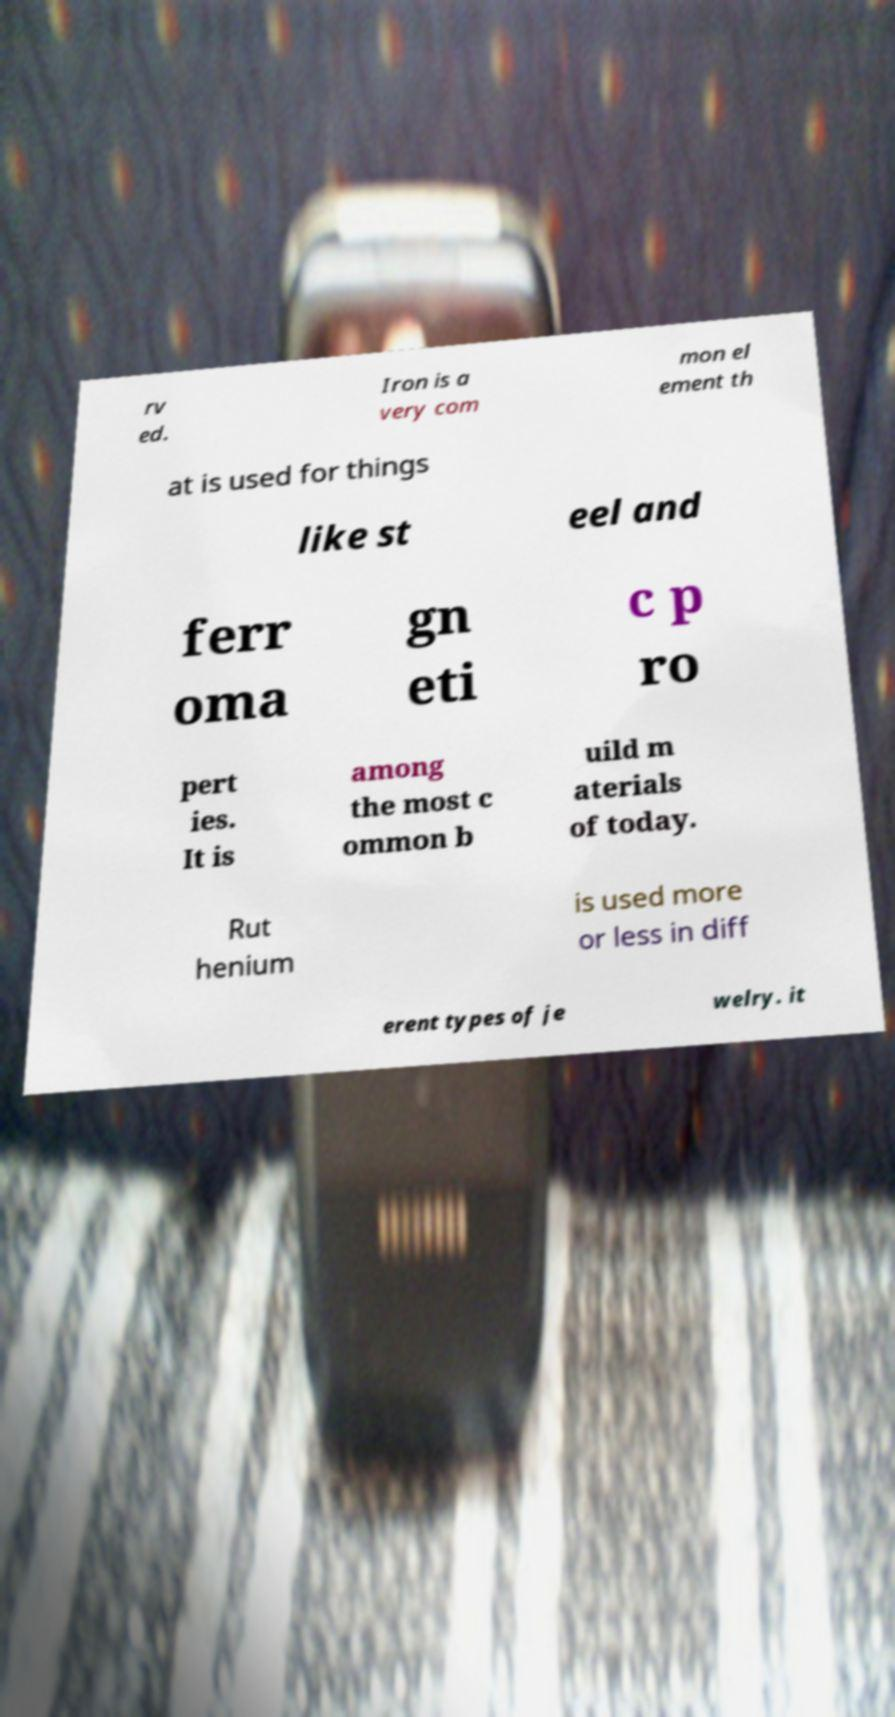Could you assist in decoding the text presented in this image and type it out clearly? rv ed. Iron is a very com mon el ement th at is used for things like st eel and ferr oma gn eti c p ro pert ies. It is among the most c ommon b uild m aterials of today. Rut henium is used more or less in diff erent types of je welry. it 